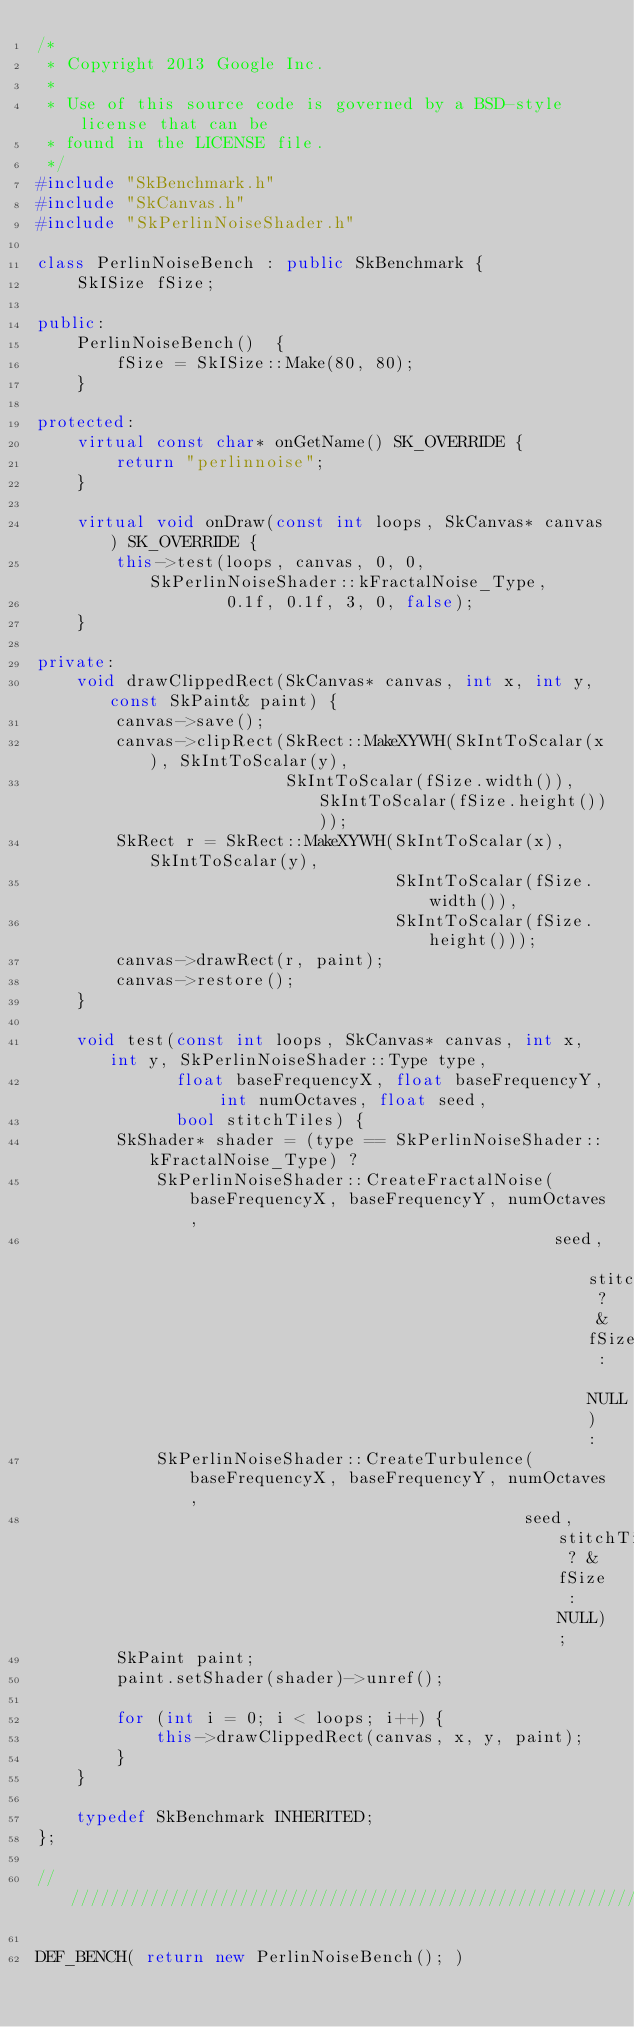<code> <loc_0><loc_0><loc_500><loc_500><_C++_>/*
 * Copyright 2013 Google Inc.
 *
 * Use of this source code is governed by a BSD-style license that can be
 * found in the LICENSE file.
 */
#include "SkBenchmark.h"
#include "SkCanvas.h"
#include "SkPerlinNoiseShader.h"

class PerlinNoiseBench : public SkBenchmark {
    SkISize fSize;

public:
    PerlinNoiseBench()  {
        fSize = SkISize::Make(80, 80);
    }

protected:
    virtual const char* onGetName() SK_OVERRIDE {
        return "perlinnoise";
    }

    virtual void onDraw(const int loops, SkCanvas* canvas) SK_OVERRIDE {
        this->test(loops, canvas, 0, 0, SkPerlinNoiseShader::kFractalNoise_Type,
                   0.1f, 0.1f, 3, 0, false);
    }

private:
    void drawClippedRect(SkCanvas* canvas, int x, int y, const SkPaint& paint) {
        canvas->save();
        canvas->clipRect(SkRect::MakeXYWH(SkIntToScalar(x), SkIntToScalar(y),
                         SkIntToScalar(fSize.width()), SkIntToScalar(fSize.height())));
        SkRect r = SkRect::MakeXYWH(SkIntToScalar(x), SkIntToScalar(y),
                                    SkIntToScalar(fSize.width()),
                                    SkIntToScalar(fSize.height()));
        canvas->drawRect(r, paint);
        canvas->restore();
    }

    void test(const int loops, SkCanvas* canvas, int x, int y, SkPerlinNoiseShader::Type type,
              float baseFrequencyX, float baseFrequencyY, int numOctaves, float seed,
              bool stitchTiles) {
        SkShader* shader = (type == SkPerlinNoiseShader::kFractalNoise_Type) ?
            SkPerlinNoiseShader::CreateFractalNoise(baseFrequencyX, baseFrequencyY, numOctaves,
                                                    seed, stitchTiles ? &fSize : NULL) :
            SkPerlinNoiseShader::CreateTurbulence(baseFrequencyX, baseFrequencyY, numOctaves,
                                                 seed, stitchTiles ? &fSize : NULL);
        SkPaint paint;
        paint.setShader(shader)->unref();

        for (int i = 0; i < loops; i++) {
            this->drawClippedRect(canvas, x, y, paint);
        }
    }

    typedef SkBenchmark INHERITED;
};

///////////////////////////////////////////////////////////////////////////////

DEF_BENCH( return new PerlinNoiseBench(); )
</code> 